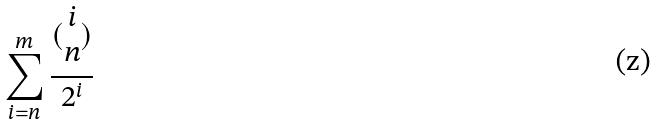Convert formula to latex. <formula><loc_0><loc_0><loc_500><loc_500>\sum _ { i = n } ^ { m } \frac { ( \begin{matrix} i \\ n \end{matrix} ) } { 2 ^ { i } }</formula> 